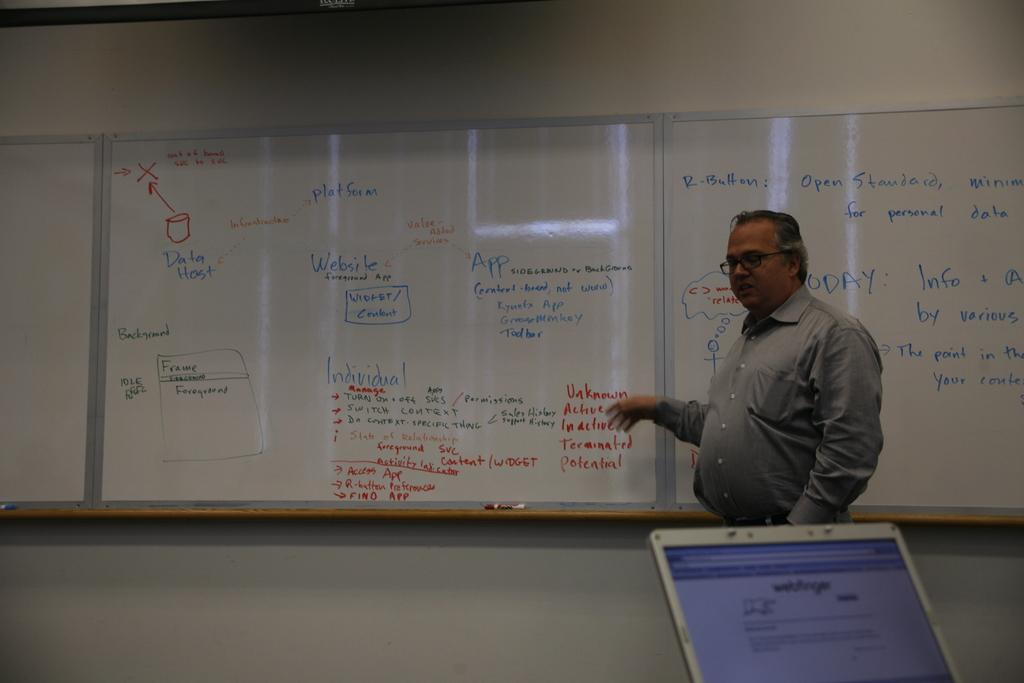Provide a one-sentence caption for the provided image. The instructor is teaching a web development class and is discussing frames and data hosts. 